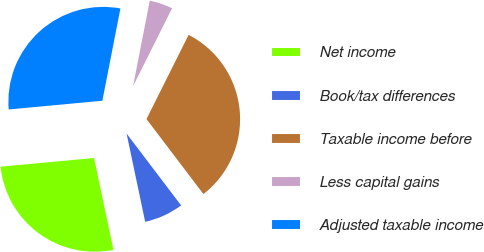<chart> <loc_0><loc_0><loc_500><loc_500><pie_chart><fcel>Net income<fcel>Book/tax differences<fcel>Taxable income before<fcel>Less capital gains<fcel>Adjusted taxable income<nl><fcel>26.83%<fcel>7.03%<fcel>32.28%<fcel>4.31%<fcel>29.55%<nl></chart> 